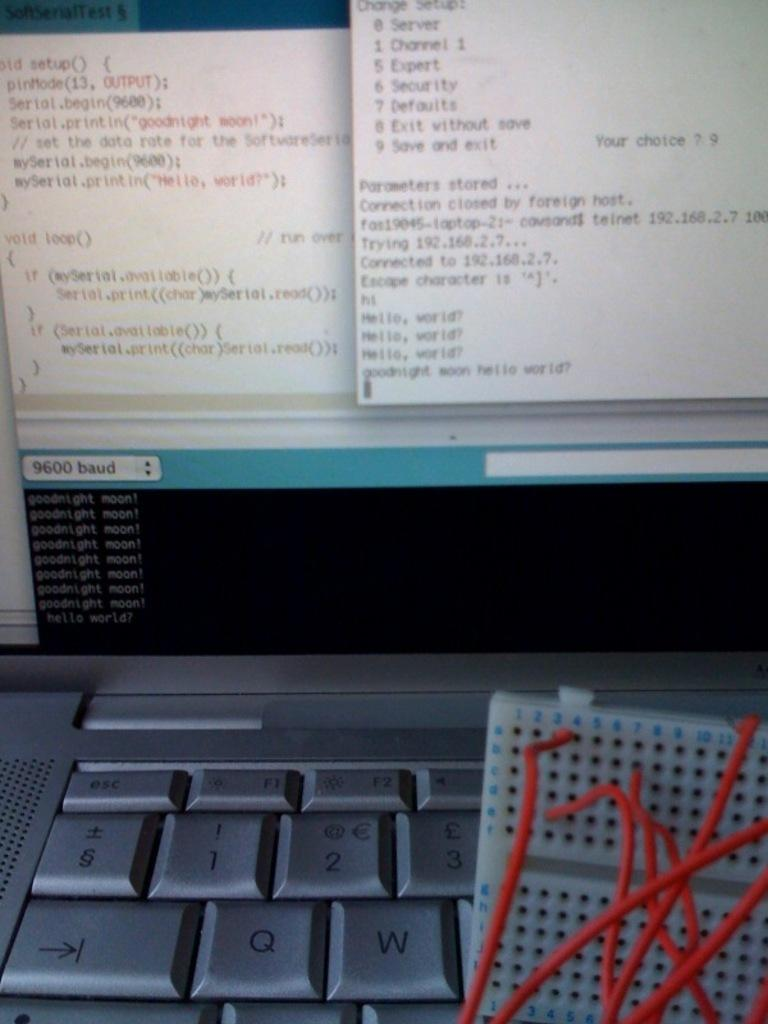<image>
Share a concise interpretation of the image provided. A computer with a setup menu on the screen and a numbered board with red wires. 